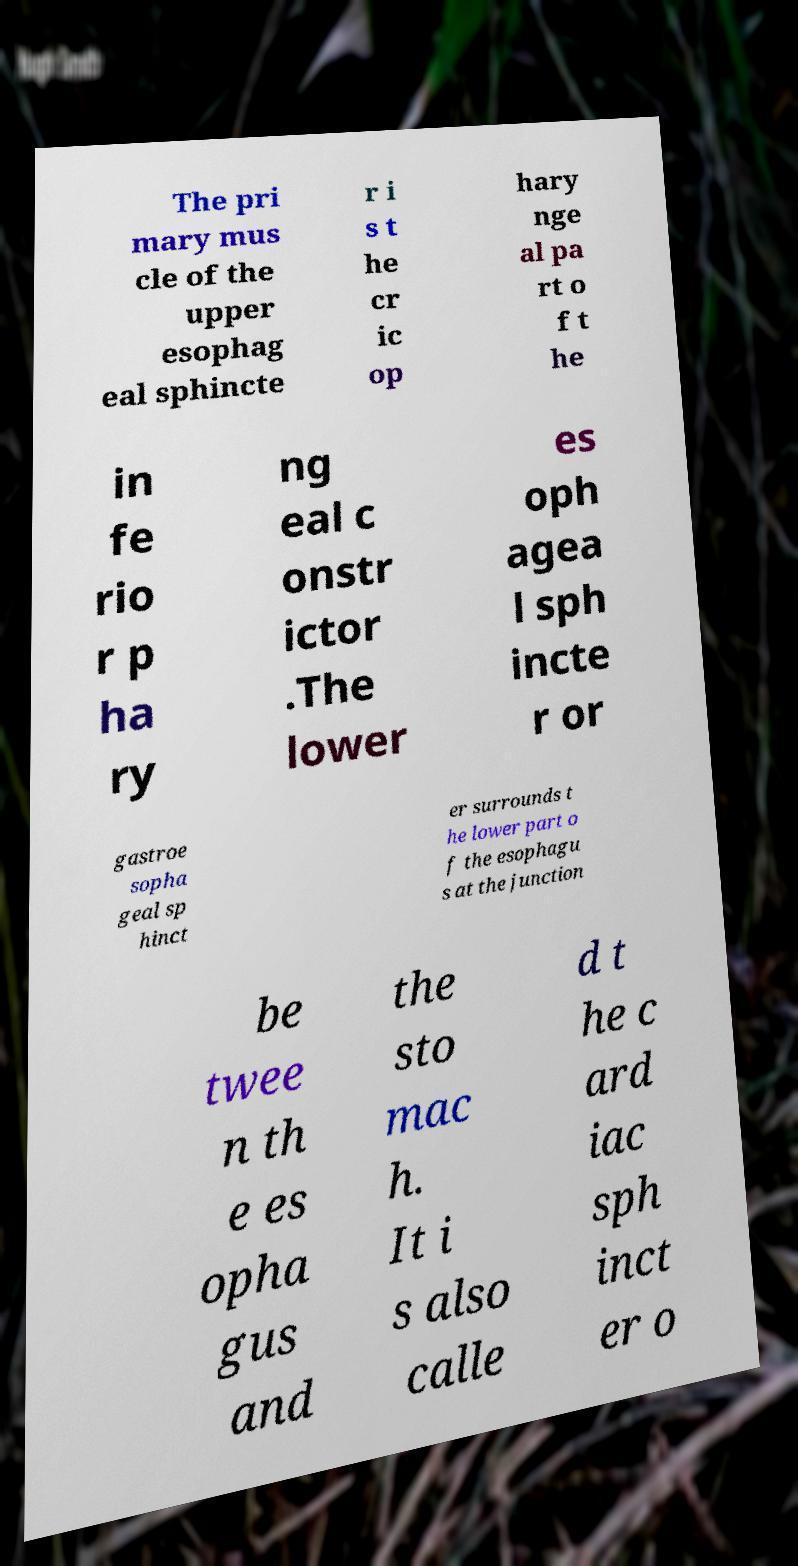Could you assist in decoding the text presented in this image and type it out clearly? The pri mary mus cle of the upper esophag eal sphincte r i s t he cr ic op hary nge al pa rt o f t he in fe rio r p ha ry ng eal c onstr ictor .The lower es oph agea l sph incte r or gastroe sopha geal sp hinct er surrounds t he lower part o f the esophagu s at the junction be twee n th e es opha gus and the sto mac h. It i s also calle d t he c ard iac sph inct er o 